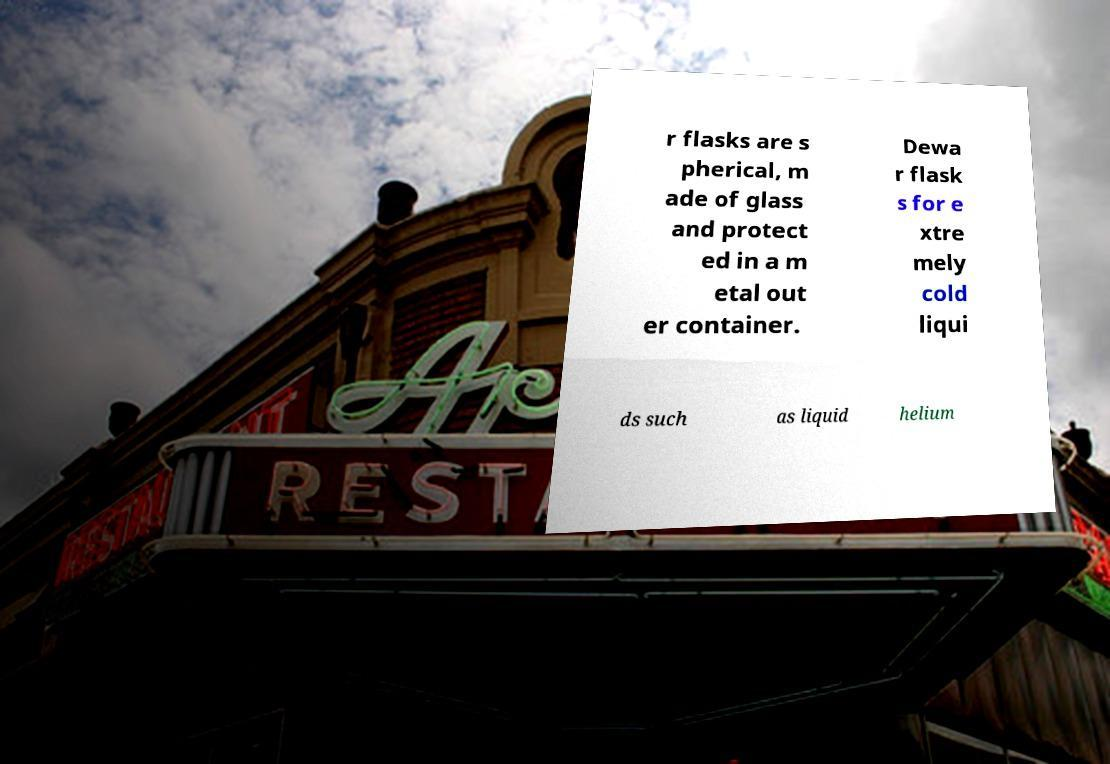Please read and relay the text visible in this image. What does it say? r flasks are s pherical, m ade of glass and protect ed in a m etal out er container. Dewa r flask s for e xtre mely cold liqui ds such as liquid helium 